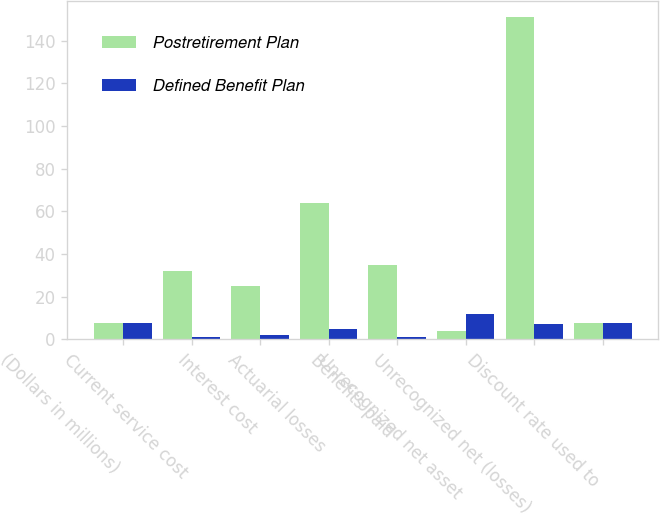Convert chart to OTSL. <chart><loc_0><loc_0><loc_500><loc_500><stacked_bar_chart><ecel><fcel>(Dollars in millions)<fcel>Current service cost<fcel>Interest cost<fcel>Actuarial losses<fcel>Benefits paid<fcel>Unrecognized net asset<fcel>Unrecognized net (losses)<fcel>Discount rate used to<nl><fcel>Postretirement Plan<fcel>7.5<fcel>32<fcel>25<fcel>64<fcel>35<fcel>4<fcel>151<fcel>7.5<nl><fcel>Defined Benefit Plan<fcel>7.5<fcel>1<fcel>2<fcel>5<fcel>1<fcel>12<fcel>7<fcel>7.5<nl></chart> 